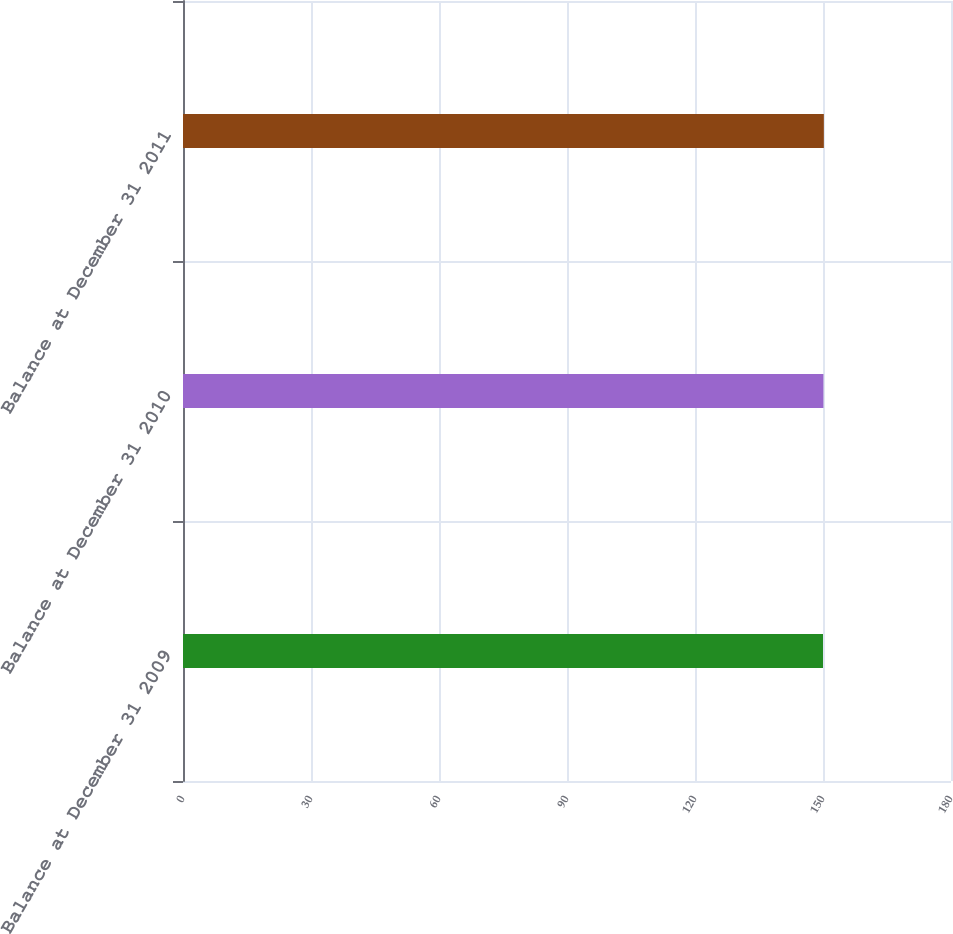Convert chart to OTSL. <chart><loc_0><loc_0><loc_500><loc_500><bar_chart><fcel>Balance at December 31 2009<fcel>Balance at December 31 2010<fcel>Balance at December 31 2011<nl><fcel>150<fcel>150.1<fcel>150.2<nl></chart> 